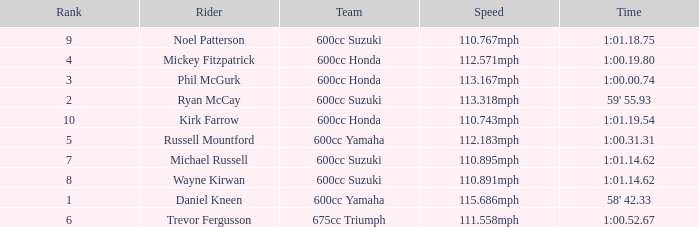How many ranks have michael russell as the rider? 7.0. 